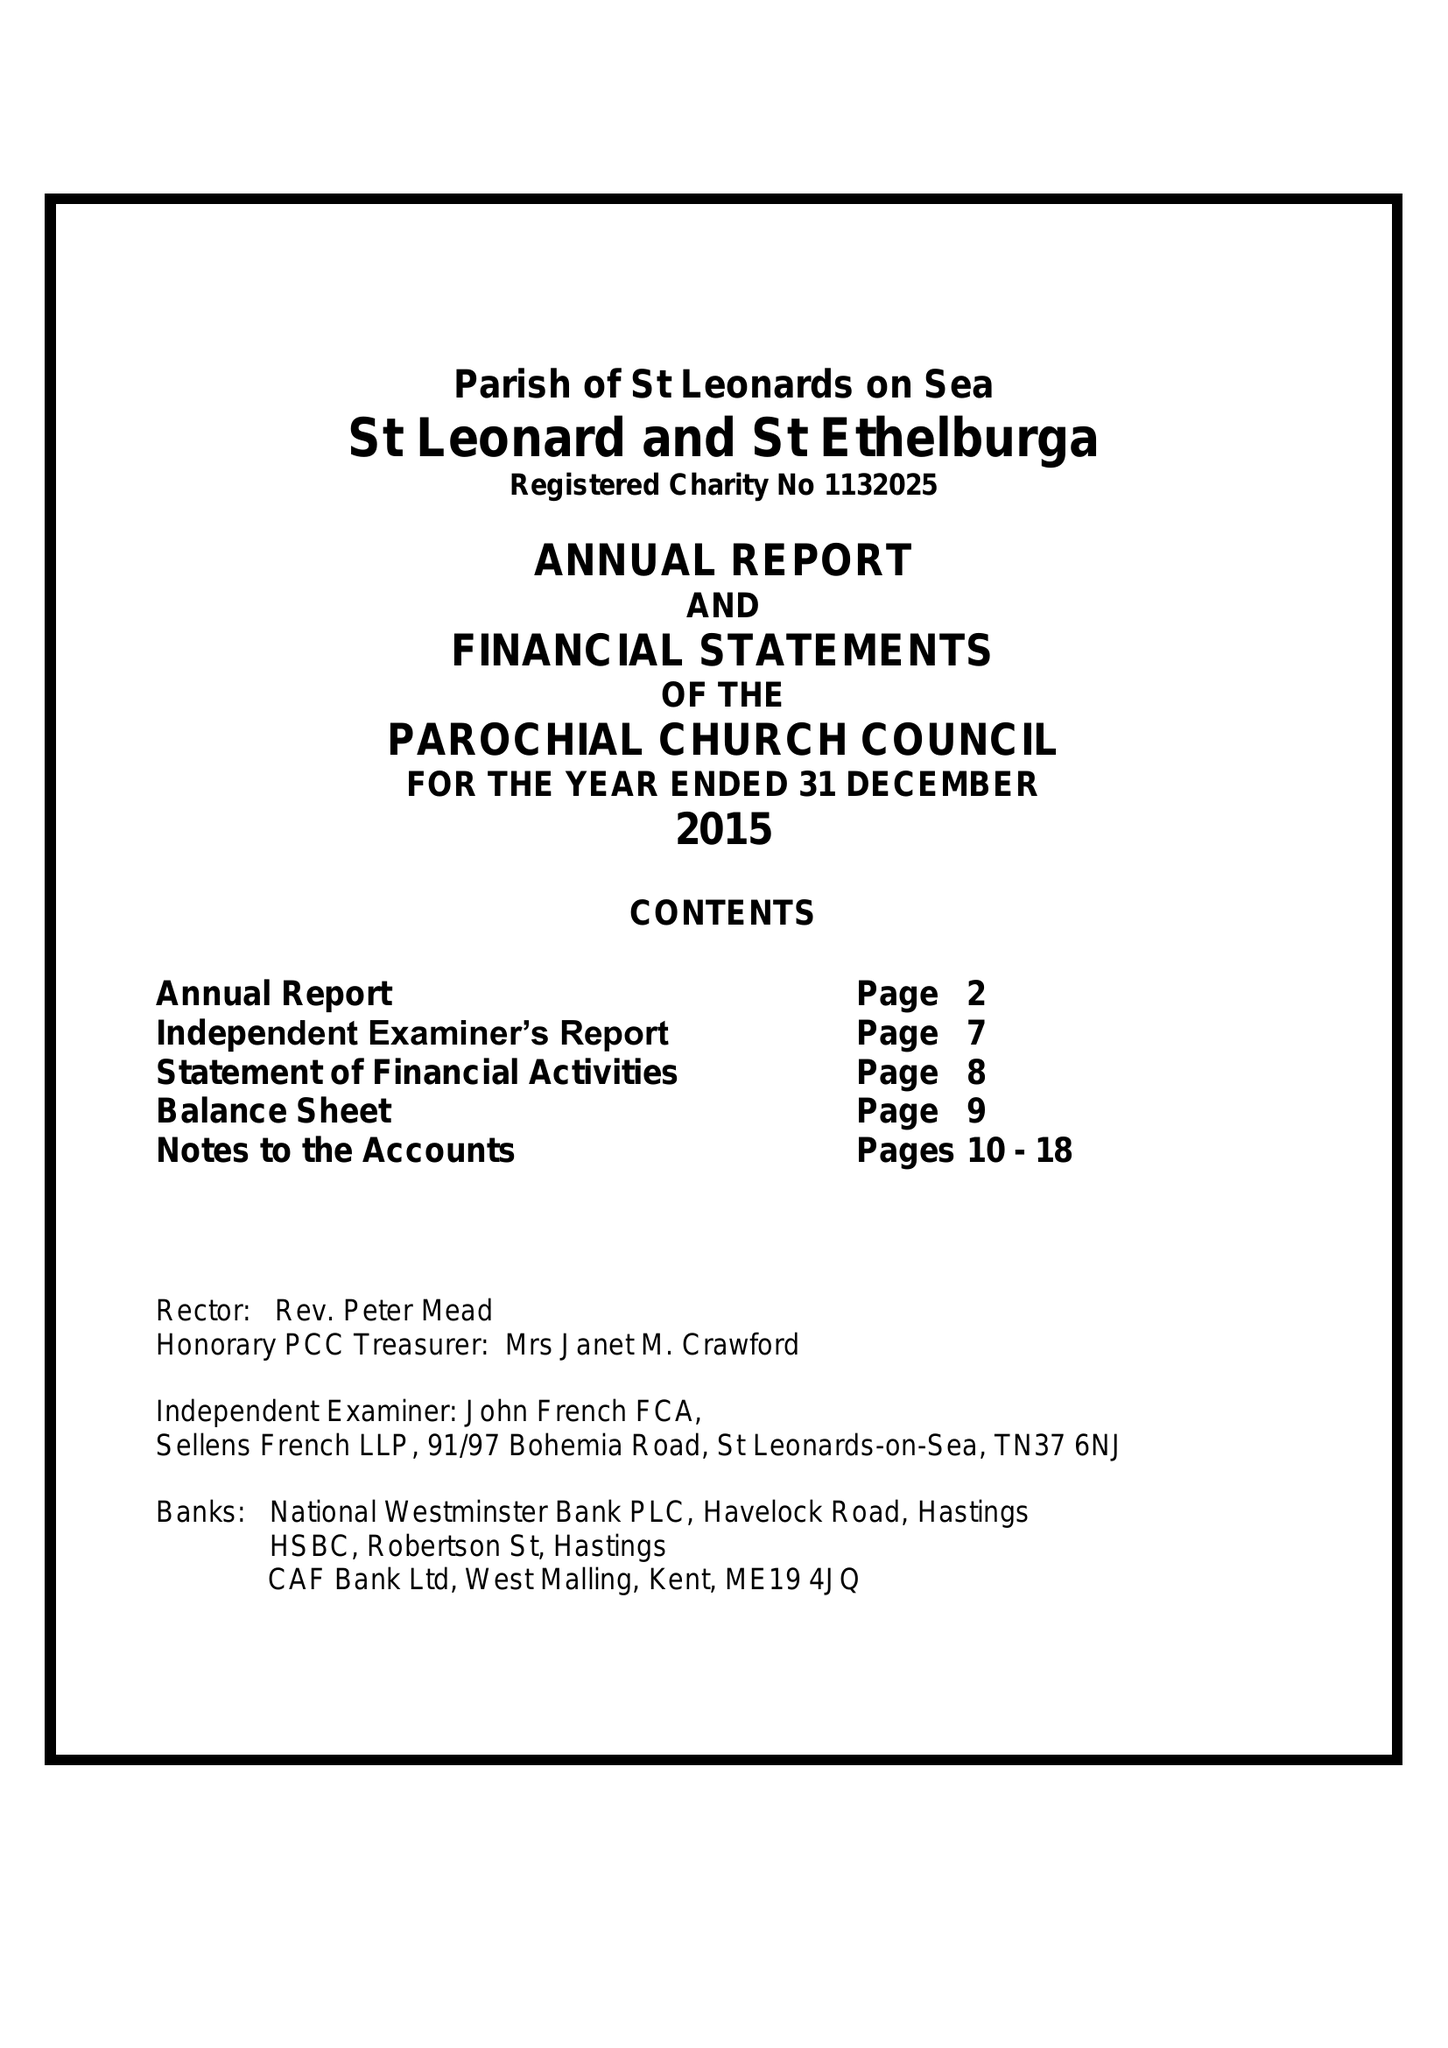What is the value for the spending_annually_in_british_pounds?
Answer the question using a single word or phrase. 84872.00 